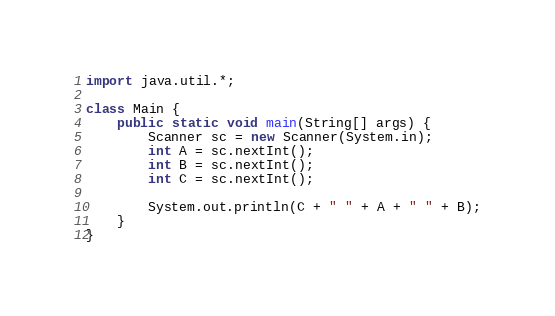<code> <loc_0><loc_0><loc_500><loc_500><_Java_>import java.util.*;

class Main {
    public static void main(String[] args) {
        Scanner sc = new Scanner(System.in);
        int A = sc.nextInt();
        int B = sc.nextInt();
        int C = sc.nextInt();

        System.out.println(C + " " + A + " " + B);
    }
}</code> 